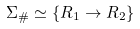Convert formula to latex. <formula><loc_0><loc_0><loc_500><loc_500>\Sigma _ { \# } \simeq \{ R _ { 1 } \rightarrow R _ { 2 } \}</formula> 